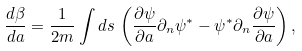Convert formula to latex. <formula><loc_0><loc_0><loc_500><loc_500>\frac { d \beta } { d a } = \frac { 1 } { 2 m } \int d s \, \left ( \frac { \partial \psi } { \partial a } \partial _ { n } \psi ^ { * } - \psi ^ { * } \partial _ { n } \frac { \partial \psi } { \partial a } \right ) ,</formula> 